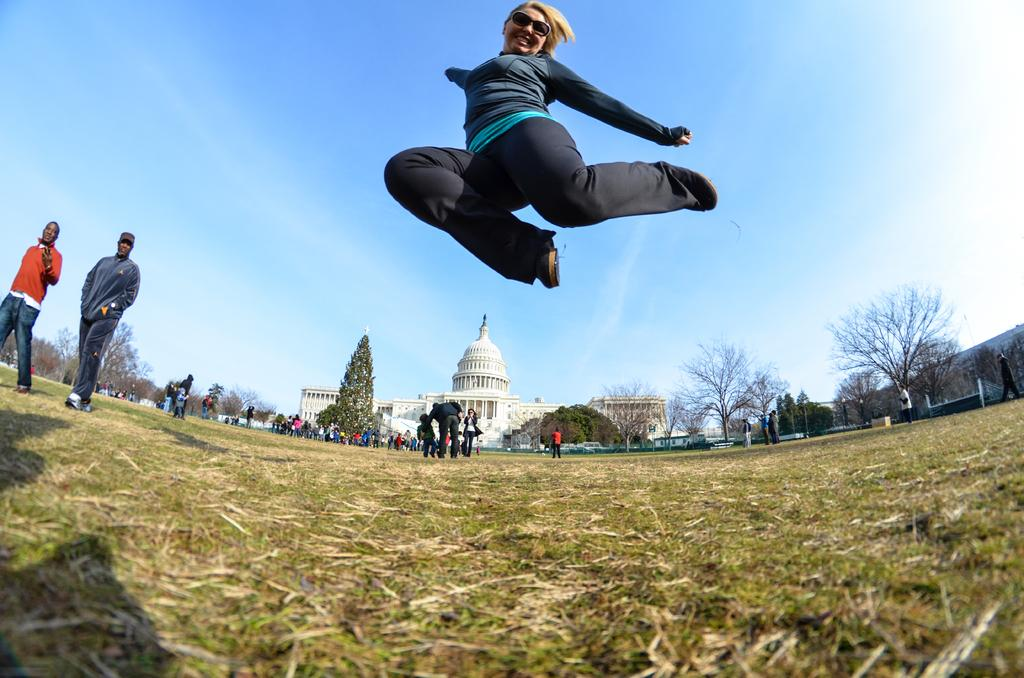What is the woman in the image doing? The woman is jumping in the image. What are the other people in the image doing? There is a group of people standing in the image. What type of natural environment is visible in the image? There are trees in the image. What type of structure is visible in the image? There is a building in the image. What is visible in the background of the image? The sky is visible in the background of the image. What type of cable can be seen connecting the woman to the trees in the image? There is no cable present in the image; the woman is simply jumping. 